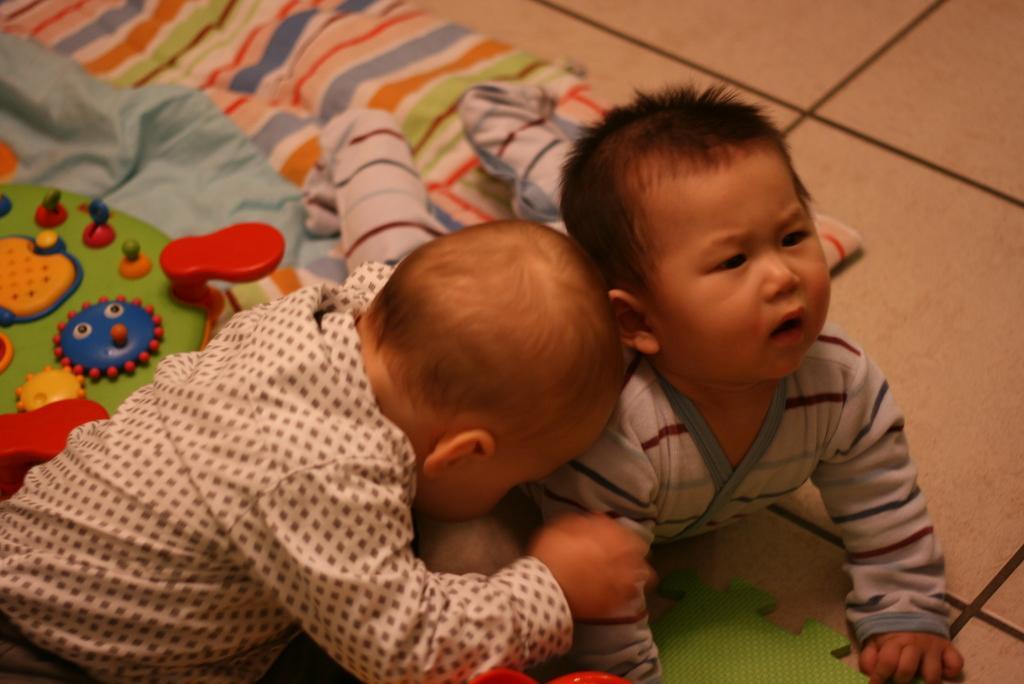Describe this image in one or two sentences. There is a baby in a shirt, keeping head on a shoulder of another baby who is lying on the floor, on which there is a cloth. 